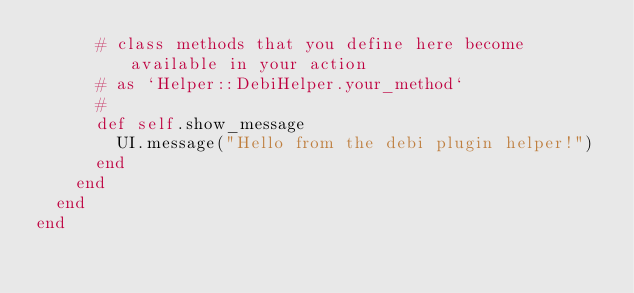<code> <loc_0><loc_0><loc_500><loc_500><_Ruby_>      # class methods that you define here become available in your action
      # as `Helper::DebiHelper.your_method`
      #
      def self.show_message
        UI.message("Hello from the debi plugin helper!")
      end
    end
  end
end
</code> 